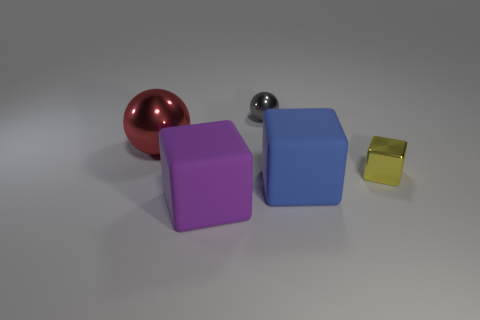Subtract all small cubes. How many cubes are left? 2 Add 2 gray spheres. How many objects exist? 7 Subtract all cyan blocks. Subtract all brown balls. How many blocks are left? 3 Subtract all spheres. How many objects are left? 3 Add 3 metallic things. How many metallic things exist? 6 Subtract 0 gray blocks. How many objects are left? 5 Subtract all green metallic cubes. Subtract all tiny yellow things. How many objects are left? 4 Add 1 large shiny things. How many large shiny things are left? 2 